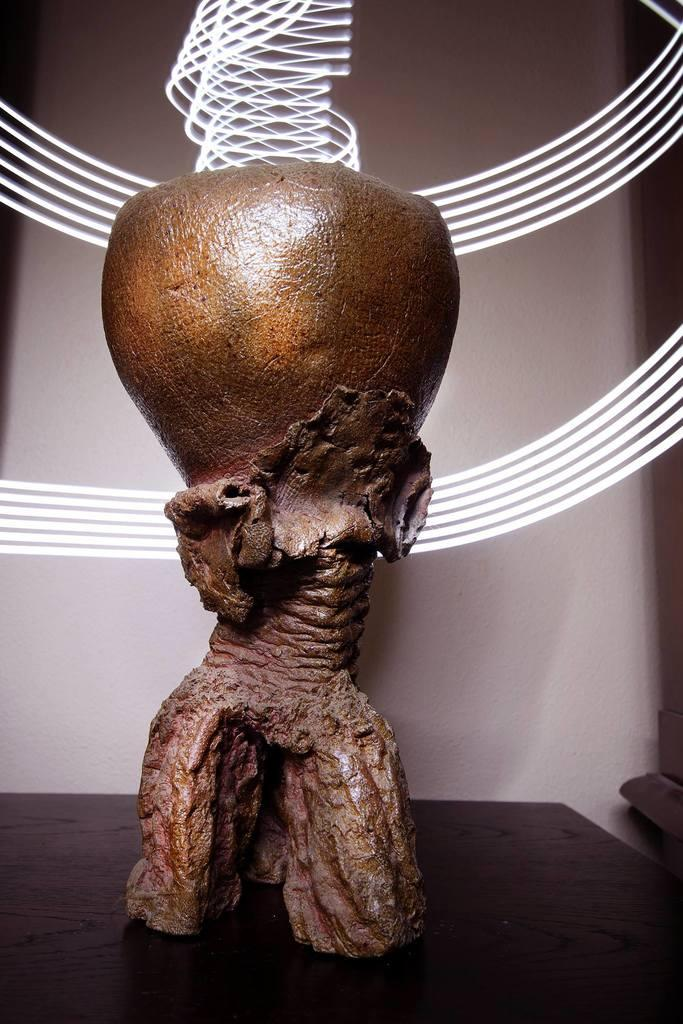What is the main subject of the image? The main subject of the image is a carved object. Where is the faucet located in the image? There is no faucet present in the image; the main subject is a carved object. What type of jelly can be seen surrounding the carved object in the image? There is no jelly present in the image; the main subject is a carved object. 